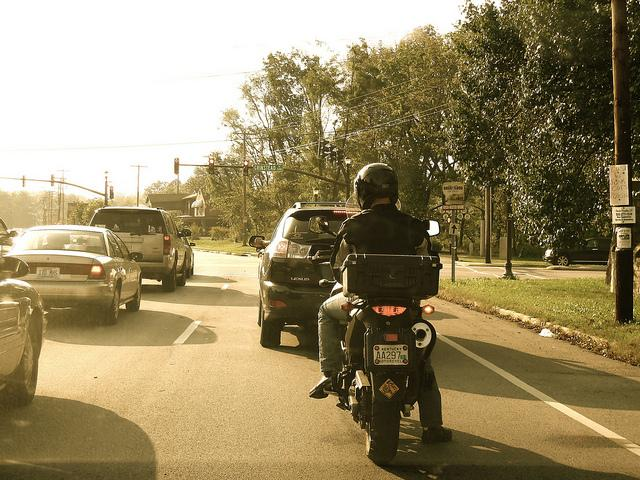For What reason does the person on the motorcycle have their right leg on the street?

Choices:
A) balance
B) tapping angrily
C) kicking
D) stop bike balance 